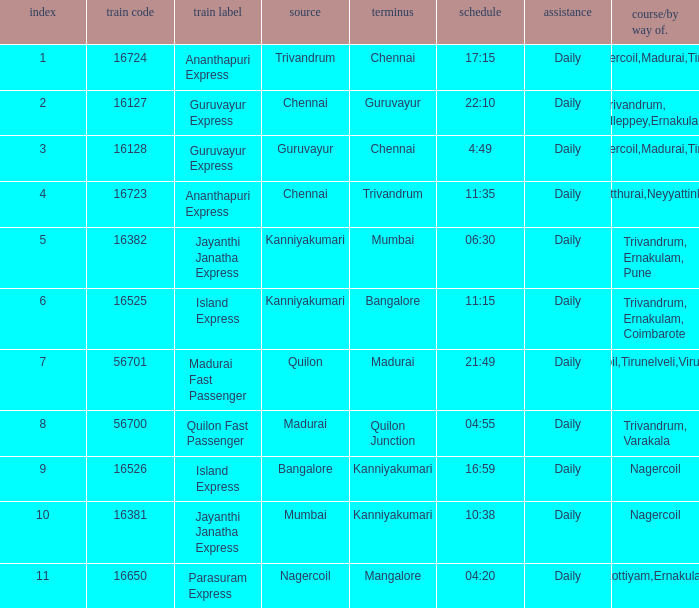What is the destination when the train number is 16526? Kanniyakumari. 